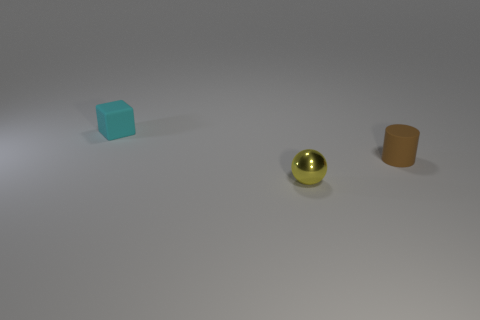Imagine these objects are part of a story. Can you create a narrative involving them? In a world where shapes are sentient beings, the three objects in the image are friends on an adventure. The blue cube, known for its steadfast and stable nature, leads the group with a calm, responsible demeanor. The shiny yellow sphere, full of energy and curiosity, tends to roll ahead in excitement. The orange cylinder, being both grounded and flexible, acts as the problem solver for the trio. Together, they embark on an epic journey across tabletops and desks, exploring vast terrains made from books, pens, and paper clips, while learning valuable lessons about teamwork and diversity. 